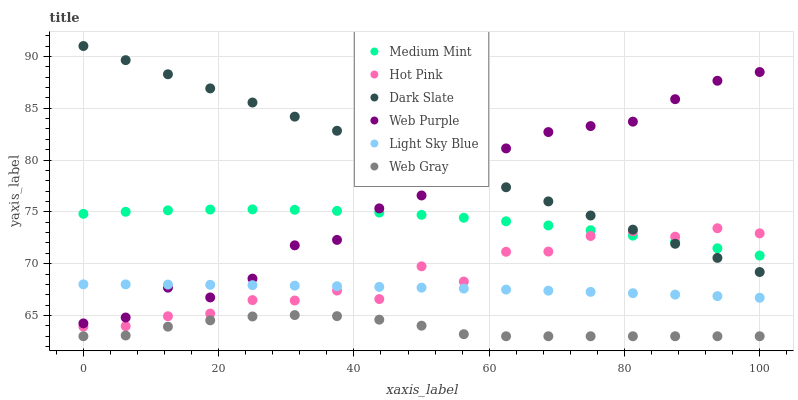Does Web Gray have the minimum area under the curve?
Answer yes or no. Yes. Does Dark Slate have the maximum area under the curve?
Answer yes or no. Yes. Does Hot Pink have the minimum area under the curve?
Answer yes or no. No. Does Hot Pink have the maximum area under the curve?
Answer yes or no. No. Is Dark Slate the smoothest?
Answer yes or no. Yes. Is Hot Pink the roughest?
Answer yes or no. Yes. Is Web Gray the smoothest?
Answer yes or no. No. Is Web Gray the roughest?
Answer yes or no. No. Does Web Gray have the lowest value?
Answer yes or no. Yes. Does Hot Pink have the lowest value?
Answer yes or no. No. Does Dark Slate have the highest value?
Answer yes or no. Yes. Does Hot Pink have the highest value?
Answer yes or no. No. Is Light Sky Blue less than Medium Mint?
Answer yes or no. Yes. Is Medium Mint greater than Web Gray?
Answer yes or no. Yes. Does Dark Slate intersect Medium Mint?
Answer yes or no. Yes. Is Dark Slate less than Medium Mint?
Answer yes or no. No. Is Dark Slate greater than Medium Mint?
Answer yes or no. No. Does Light Sky Blue intersect Medium Mint?
Answer yes or no. No. 